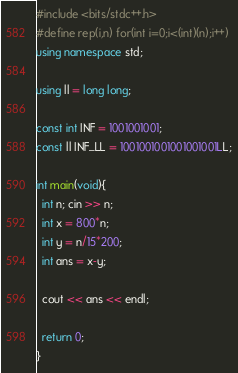Convert code to text. <code><loc_0><loc_0><loc_500><loc_500><_C++_>#include <bits/stdc++.h>
#define rep(i,n) for(int i=0;i<(int)(n);i++)
using namespace std;

using ll = long long;

const int INF = 1001001001;
const ll INF_LL = 1001001001001001001LL;

int main(void){
  int n; cin >> n;
  int x = 800*n;
  int y = n/15*200;
  int ans = x-y;

  cout << ans << endl;
  
  return 0;
}
</code> 